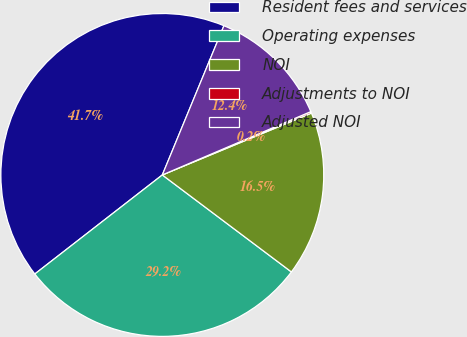Convert chart to OTSL. <chart><loc_0><loc_0><loc_500><loc_500><pie_chart><fcel>Resident fees and services<fcel>Operating expenses<fcel>NOI<fcel>Adjustments to NOI<fcel>Adjusted NOI<nl><fcel>41.74%<fcel>29.23%<fcel>16.51%<fcel>0.16%<fcel>12.35%<nl></chart> 